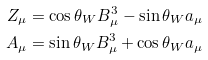Convert formula to latex. <formula><loc_0><loc_0><loc_500><loc_500>Z _ { \mu } & = \cos \theta _ { W } B ^ { 3 } _ { \mu } - \sin \theta _ { W } a _ { \mu } \\ A _ { \mu } & = \sin \theta _ { W } B ^ { 3 } _ { \mu } + \cos \theta _ { W } a _ { \mu }</formula> 